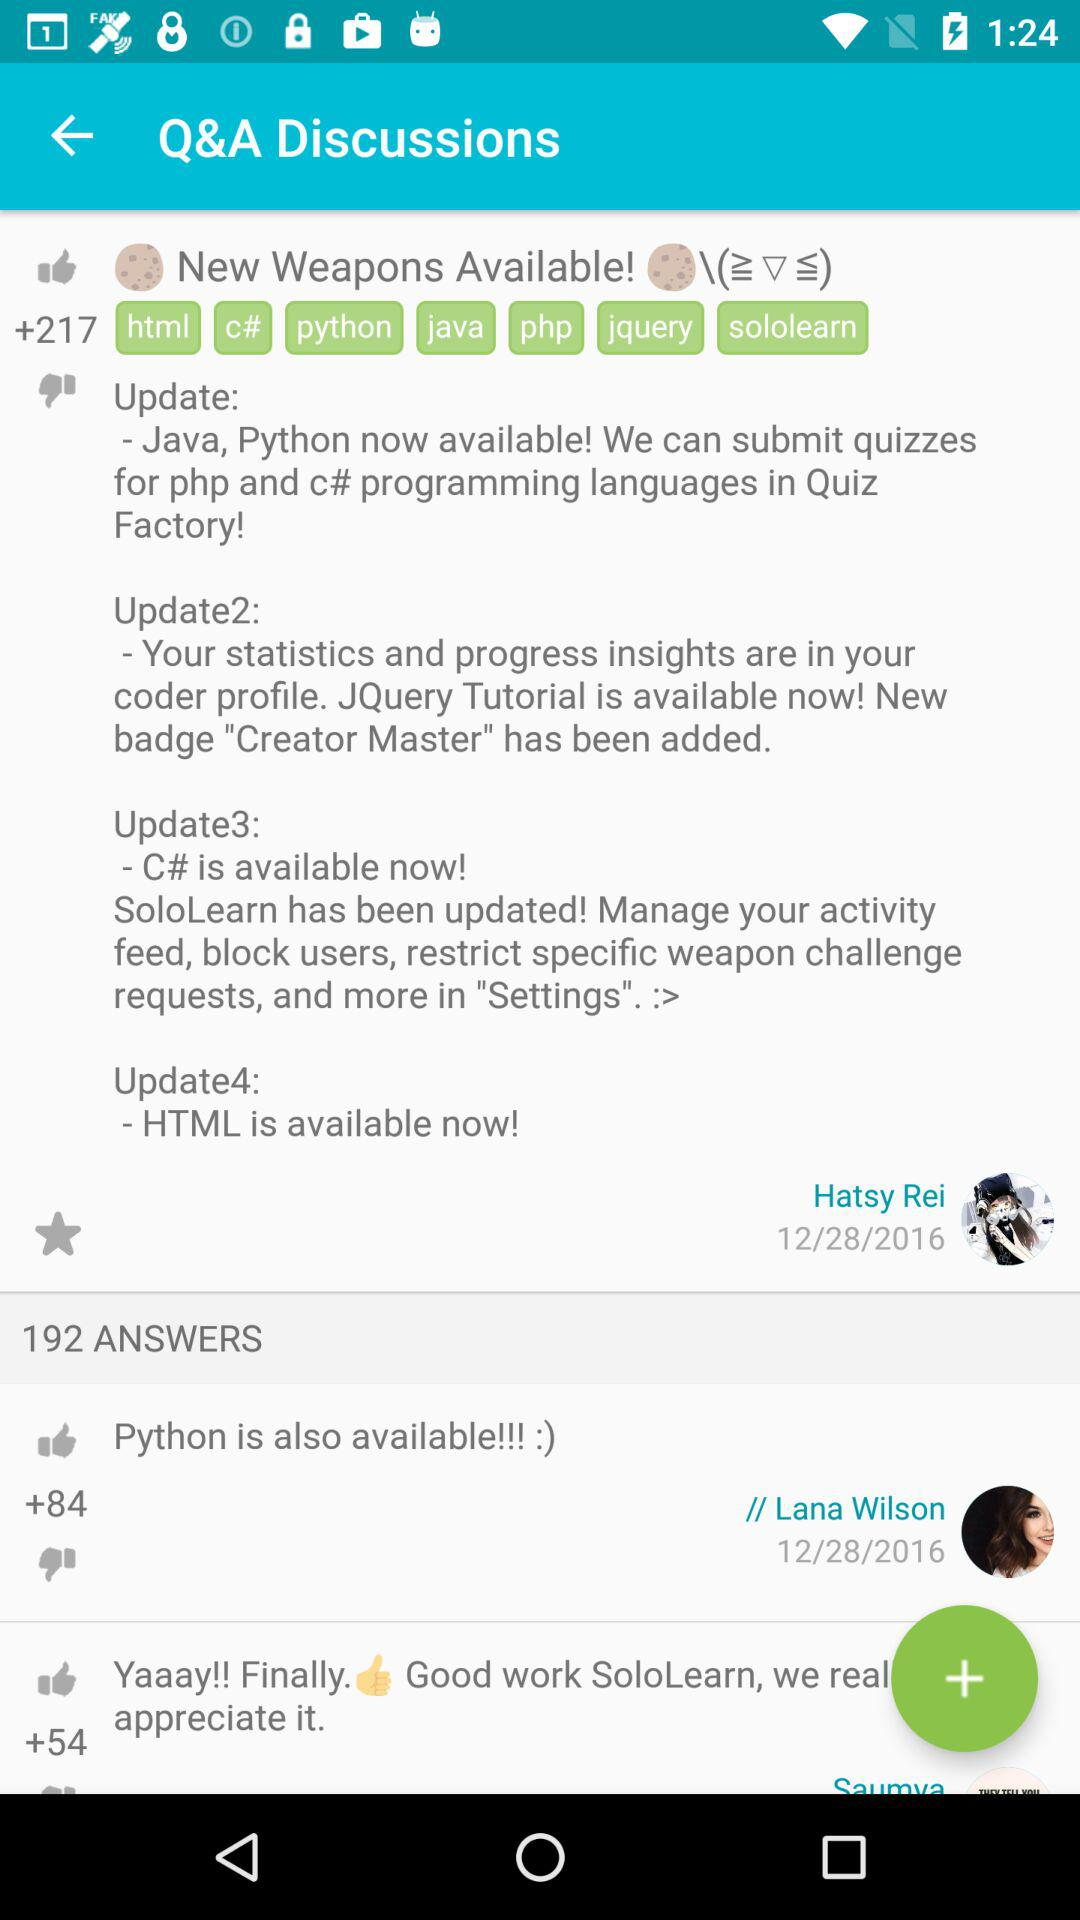What is "Update4"? The "Update4" is "HTML is available now!". 